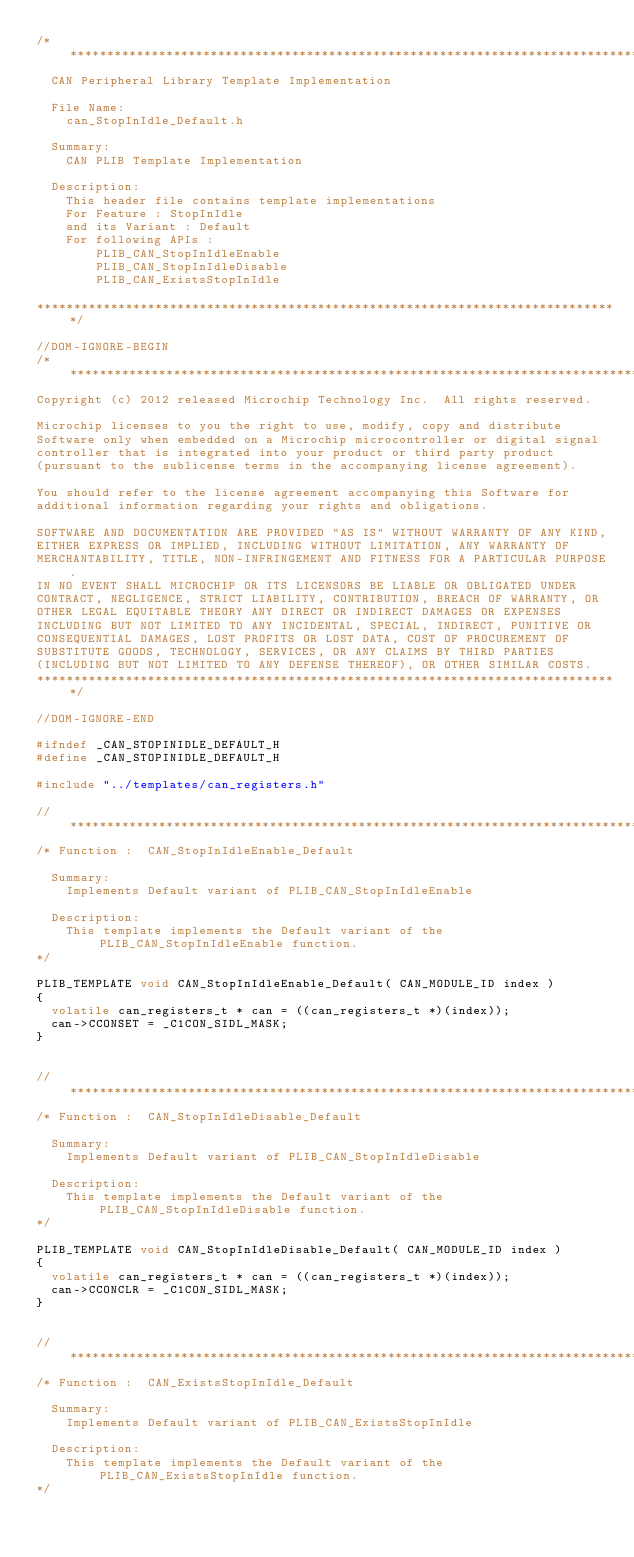<code> <loc_0><loc_0><loc_500><loc_500><_C_>/*******************************************************************************
  CAN Peripheral Library Template Implementation

  File Name:
    can_StopInIdle_Default.h

  Summary:
    CAN PLIB Template Implementation

  Description:
    This header file contains template implementations
    For Feature : StopInIdle
    and its Variant : Default
    For following APIs :
        PLIB_CAN_StopInIdleEnable
        PLIB_CAN_StopInIdleDisable
        PLIB_CAN_ExistsStopInIdle

*******************************************************************************/

//DOM-IGNORE-BEGIN
/*******************************************************************************
Copyright (c) 2012 released Microchip Technology Inc.  All rights reserved.

Microchip licenses to you the right to use, modify, copy and distribute
Software only when embedded on a Microchip microcontroller or digital signal
controller that is integrated into your product or third party product
(pursuant to the sublicense terms in the accompanying license agreement).

You should refer to the license agreement accompanying this Software for
additional information regarding your rights and obligations.

SOFTWARE AND DOCUMENTATION ARE PROVIDED "AS IS" WITHOUT WARRANTY OF ANY KIND,
EITHER EXPRESS OR IMPLIED, INCLUDING WITHOUT LIMITATION, ANY WARRANTY OF
MERCHANTABILITY, TITLE, NON-INFRINGEMENT AND FITNESS FOR A PARTICULAR PURPOSE.
IN NO EVENT SHALL MICROCHIP OR ITS LICENSORS BE LIABLE OR OBLIGATED UNDER
CONTRACT, NEGLIGENCE, STRICT LIABILITY, CONTRIBUTION, BREACH OF WARRANTY, OR
OTHER LEGAL EQUITABLE THEORY ANY DIRECT OR INDIRECT DAMAGES OR EXPENSES
INCLUDING BUT NOT LIMITED TO ANY INCIDENTAL, SPECIAL, INDIRECT, PUNITIVE OR
CONSEQUENTIAL DAMAGES, LOST PROFITS OR LOST DATA, COST OF PROCUREMENT OF
SUBSTITUTE GOODS, TECHNOLOGY, SERVICES, OR ANY CLAIMS BY THIRD PARTIES
(INCLUDING BUT NOT LIMITED TO ANY DEFENSE THEREOF), OR OTHER SIMILAR COSTS.
*******************************************************************************/

//DOM-IGNORE-END

#ifndef _CAN_STOPINIDLE_DEFAULT_H
#define _CAN_STOPINIDLE_DEFAULT_H

#include "../templates/can_registers.h"

//******************************************************************************
/* Function :  CAN_StopInIdleEnable_Default

  Summary:
    Implements Default variant of PLIB_CAN_StopInIdleEnable 

  Description:
    This template implements the Default variant of the PLIB_CAN_StopInIdleEnable function.
*/

PLIB_TEMPLATE void CAN_StopInIdleEnable_Default( CAN_MODULE_ID index )
{
	volatile can_registers_t * can = ((can_registers_t *)(index));
	can->CCONSET = _C1CON_SIDL_MASK;
}


//******************************************************************************
/* Function :  CAN_StopInIdleDisable_Default

  Summary:
    Implements Default variant of PLIB_CAN_StopInIdleDisable 

  Description:
    This template implements the Default variant of the PLIB_CAN_StopInIdleDisable function.
*/

PLIB_TEMPLATE void CAN_StopInIdleDisable_Default( CAN_MODULE_ID index )
{
	volatile can_registers_t * can = ((can_registers_t *)(index));
	can->CCONCLR = _C1CON_SIDL_MASK;
}


//******************************************************************************
/* Function :  CAN_ExistsStopInIdle_Default

  Summary:
    Implements Default variant of PLIB_CAN_ExistsStopInIdle

  Description:
    This template implements the Default variant of the PLIB_CAN_ExistsStopInIdle function.
*/
</code> 